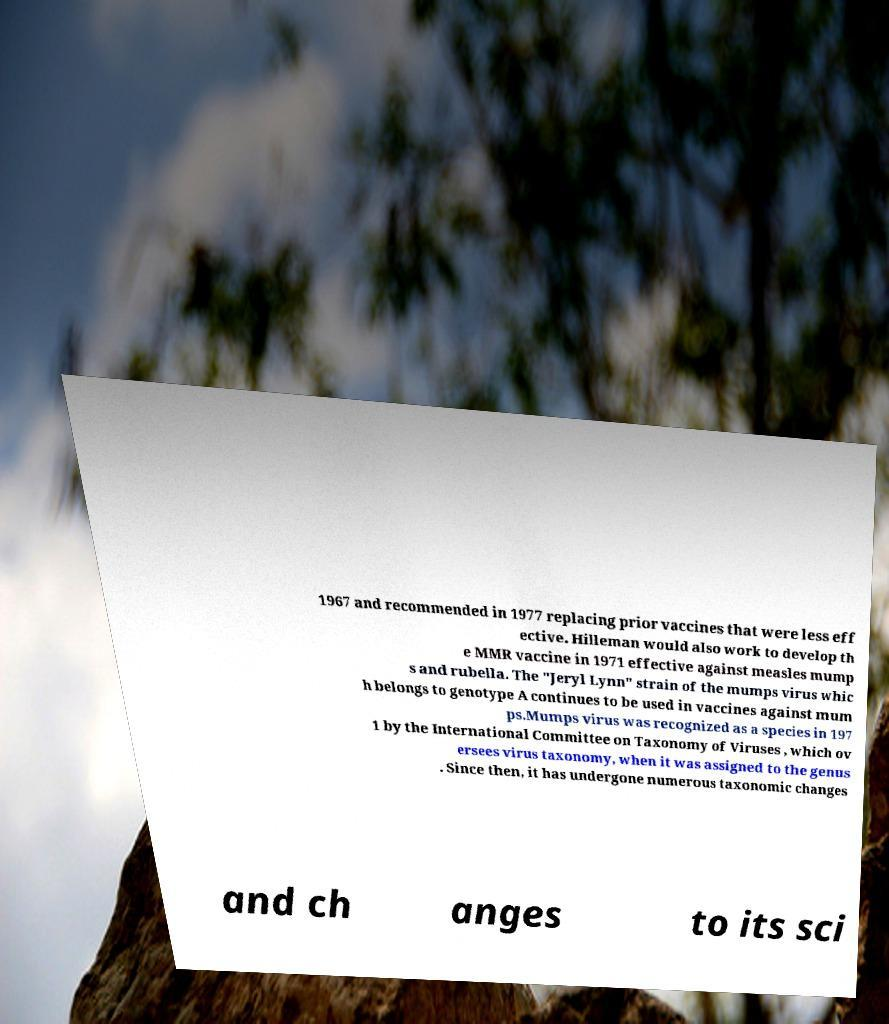Please identify and transcribe the text found in this image. 1967 and recommended in 1977 replacing prior vaccines that were less eff ective. Hilleman would also work to develop th e MMR vaccine in 1971 effective against measles mump s and rubella. The "Jeryl Lynn" strain of the mumps virus whic h belongs to genotype A continues to be used in vaccines against mum ps.Mumps virus was recognized as a species in 197 1 by the International Committee on Taxonomy of Viruses , which ov ersees virus taxonomy, when it was assigned to the genus . Since then, it has undergone numerous taxonomic changes and ch anges to its sci 